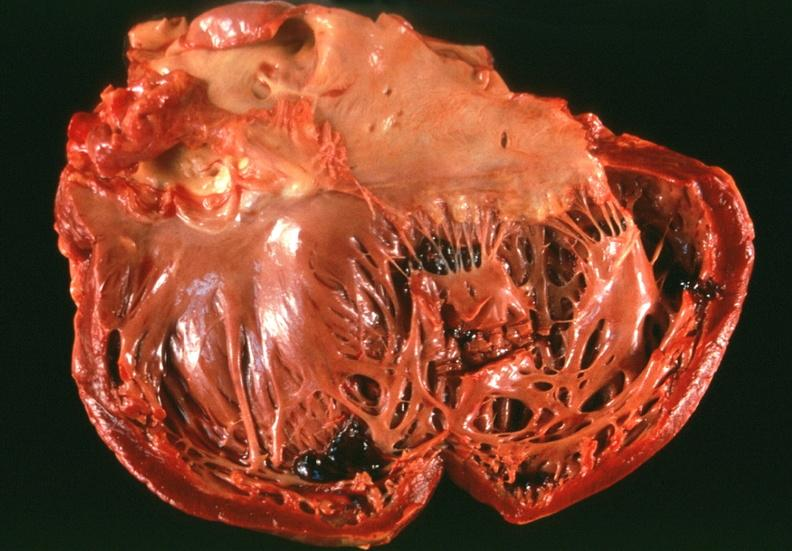s tuberculosis present?
Answer the question using a single word or phrase. No 